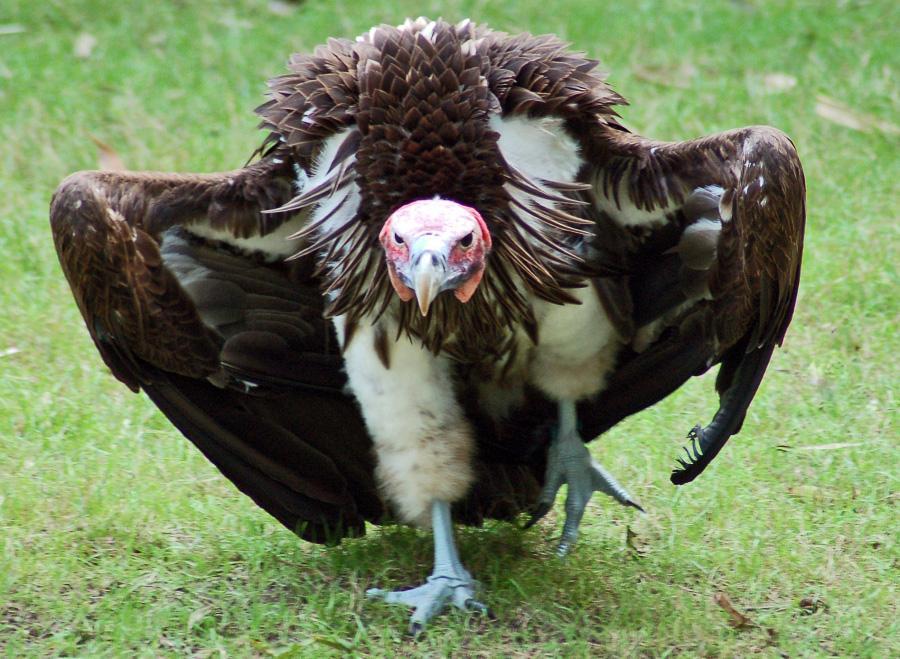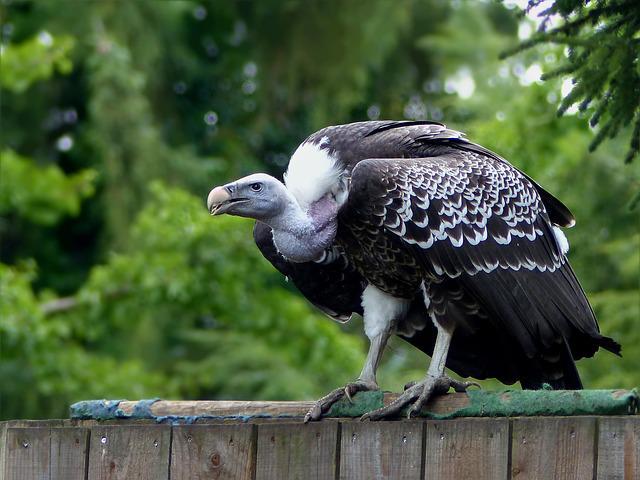The first image is the image on the left, the second image is the image on the right. Given the left and right images, does the statement "The images contain baby birds" hold true? Answer yes or no. No. 